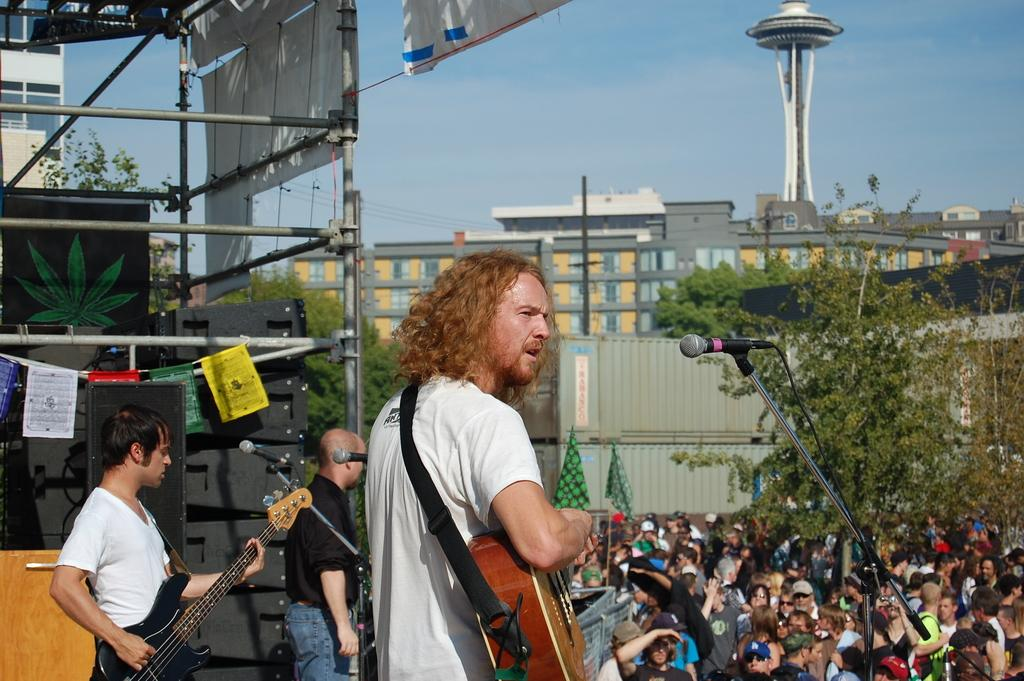How many people are playing guitar in the image? There are two persons playing guitar in the image. What is in front of the two persons playing guitar? There is a microphone in front of the two persons. What might be the purpose of the microphone? The microphone might be used for amplifying the sound of the guitars or for the two persons to sing. Can you describe the audience in the image? There are many people watching the two persons playing guitar. What type of design can be seen on the balloon floating above the two persons? There is no balloon present in the image, so it is not possible to answer that question. 